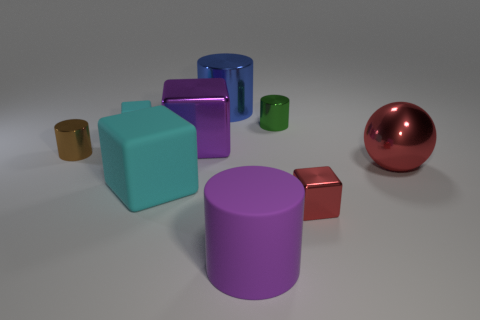Subtract 1 blocks. How many blocks are left? 3 Subtract all cylinders. How many objects are left? 5 Subtract 0 yellow blocks. How many objects are left? 9 Subtract all purple matte objects. Subtract all small red shiny cubes. How many objects are left? 7 Add 3 large balls. How many large balls are left? 4 Add 9 large rubber blocks. How many large rubber blocks exist? 10 